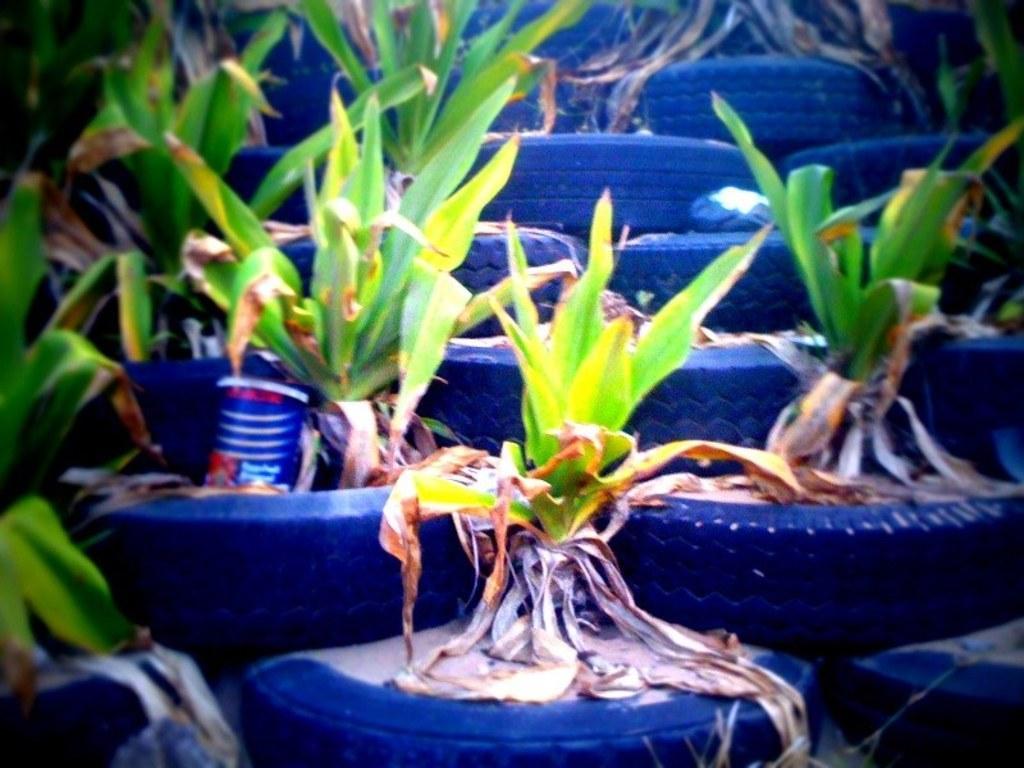Could you give a brief overview of what you see in this image? In this image we can see plants in a tyres. 